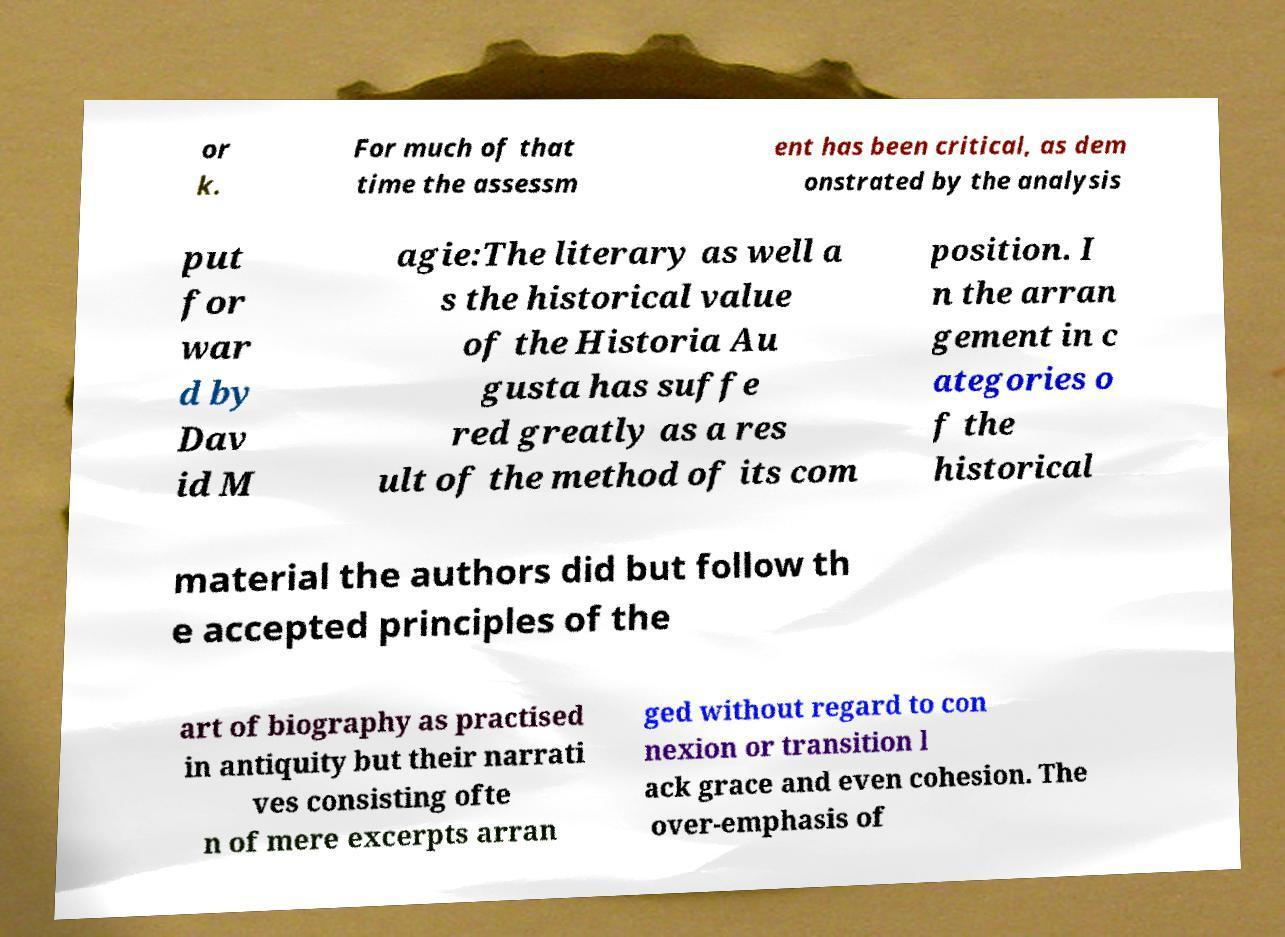I need the written content from this picture converted into text. Can you do that? or k. For much of that time the assessm ent has been critical, as dem onstrated by the analysis put for war d by Dav id M agie:The literary as well a s the historical value of the Historia Au gusta has suffe red greatly as a res ult of the method of its com position. I n the arran gement in c ategories o f the historical material the authors did but follow th e accepted principles of the art of biography as practised in antiquity but their narrati ves consisting ofte n of mere excerpts arran ged without regard to con nexion or transition l ack grace and even cohesion. The over-emphasis of 